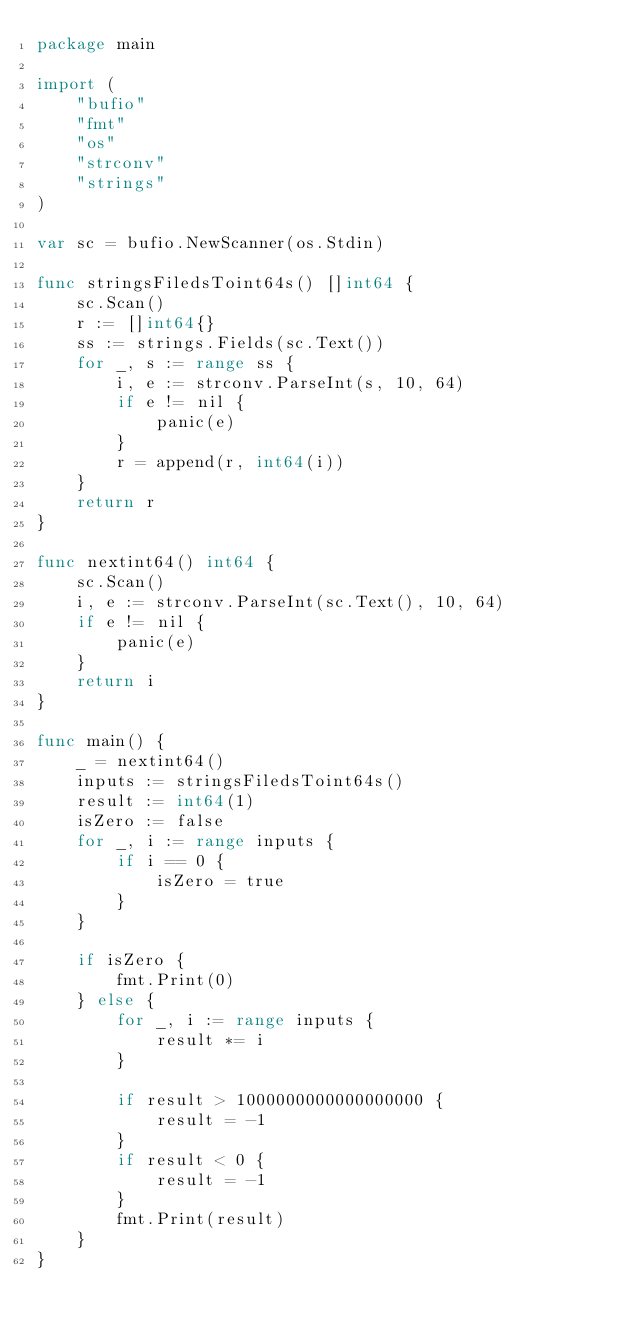Convert code to text. <code><loc_0><loc_0><loc_500><loc_500><_Go_>package main

import (
	"bufio"
	"fmt"
	"os"
	"strconv"
	"strings"
)

var sc = bufio.NewScanner(os.Stdin)

func stringsFiledsToint64s() []int64 {
	sc.Scan()
	r := []int64{}
	ss := strings.Fields(sc.Text())
	for _, s := range ss {
		i, e := strconv.ParseInt(s, 10, 64)
		if e != nil {
			panic(e)
		}
		r = append(r, int64(i))
	}
	return r
}

func nextint64() int64 {
	sc.Scan()
	i, e := strconv.ParseInt(sc.Text(), 10, 64)
	if e != nil {
		panic(e)
	}
	return i
}

func main() {
	_ = nextint64()
	inputs := stringsFiledsToint64s()
	result := int64(1)
	isZero := false
	for _, i := range inputs {
		if i == 0 {
			isZero = true
		}
	}

	if isZero {
		fmt.Print(0)
	} else {
		for _, i := range inputs {
			result *= i
		}

		if result > 1000000000000000000 {
			result = -1
		}
		if result < 0 {
			result = -1
		}
		fmt.Print(result)
	}
}
</code> 